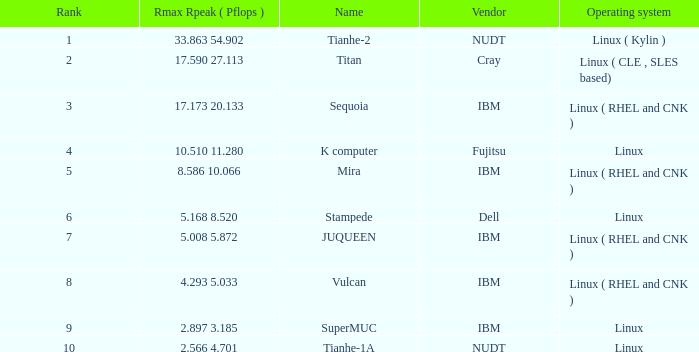133? 3.0. 